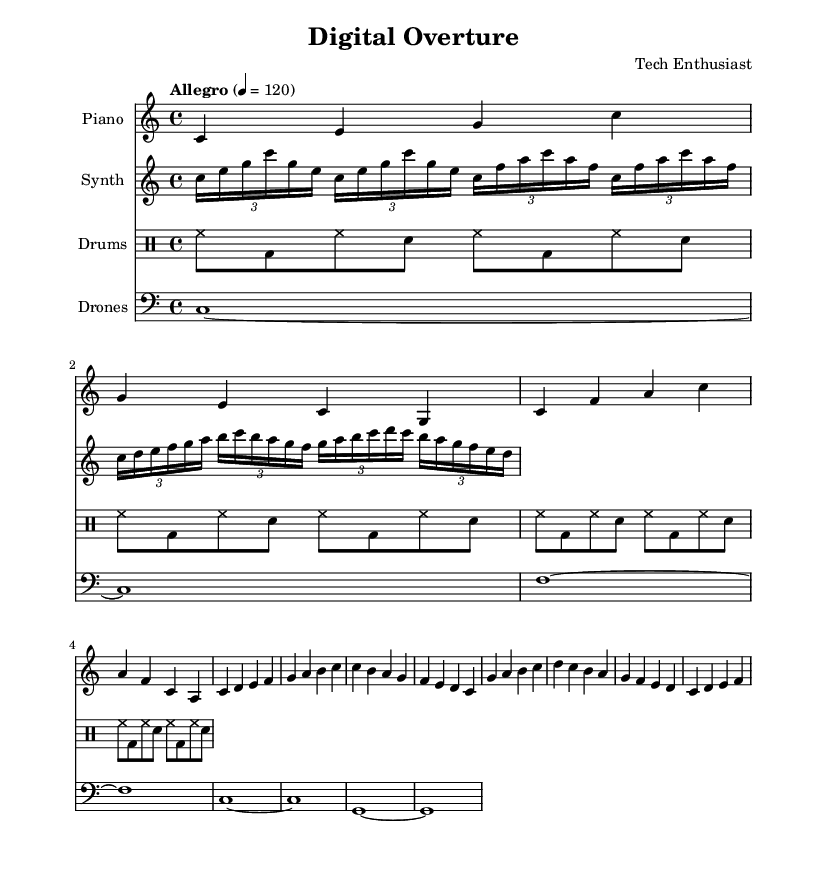What is the key signature of this music? The key signature is C major, which has no sharps or flats.
Answer: C major What is the time signature? The time signature can be found at the beginning of the staff and is indicated as 4/4, meaning there are four beats per measure, and the quarter note gets one beat.
Answer: 4/4 What is the tempo marking of the piece? The tempo marking indicates that the piece should be played "Allegro" at a speed of 120 beats per minute, which sets a lively mood for the performance.
Answer: Allegro 4 = 120 How many instruments are included in the score? The score features four different instruments: Piano, Synth, Drums, and Drones, which contribute to the texture of the composition.
Answer: Four What is the rhythmic pattern used in the drum kit? The drum pattern consists of a repeated sequence featuring hi-hat, bass drum, and snare drum, which creates a driving rhythmic foundation throughout the piece.
Answer: Repeated sequence of hi-hat, bass drum, and snare drum Which electronic instrument is indicated in the score? The score includes a synthesizer, which is specifically notated as "Synth" and plays unique melodic lines distinct from the acoustic instruments.
Answer: Synthesizer What type of sound does the drones section produce? The drones section produces a sustained sound that underpins the harmonic structure of the piece, providing a continuous tonal foundation.
Answer: Sustained sound 